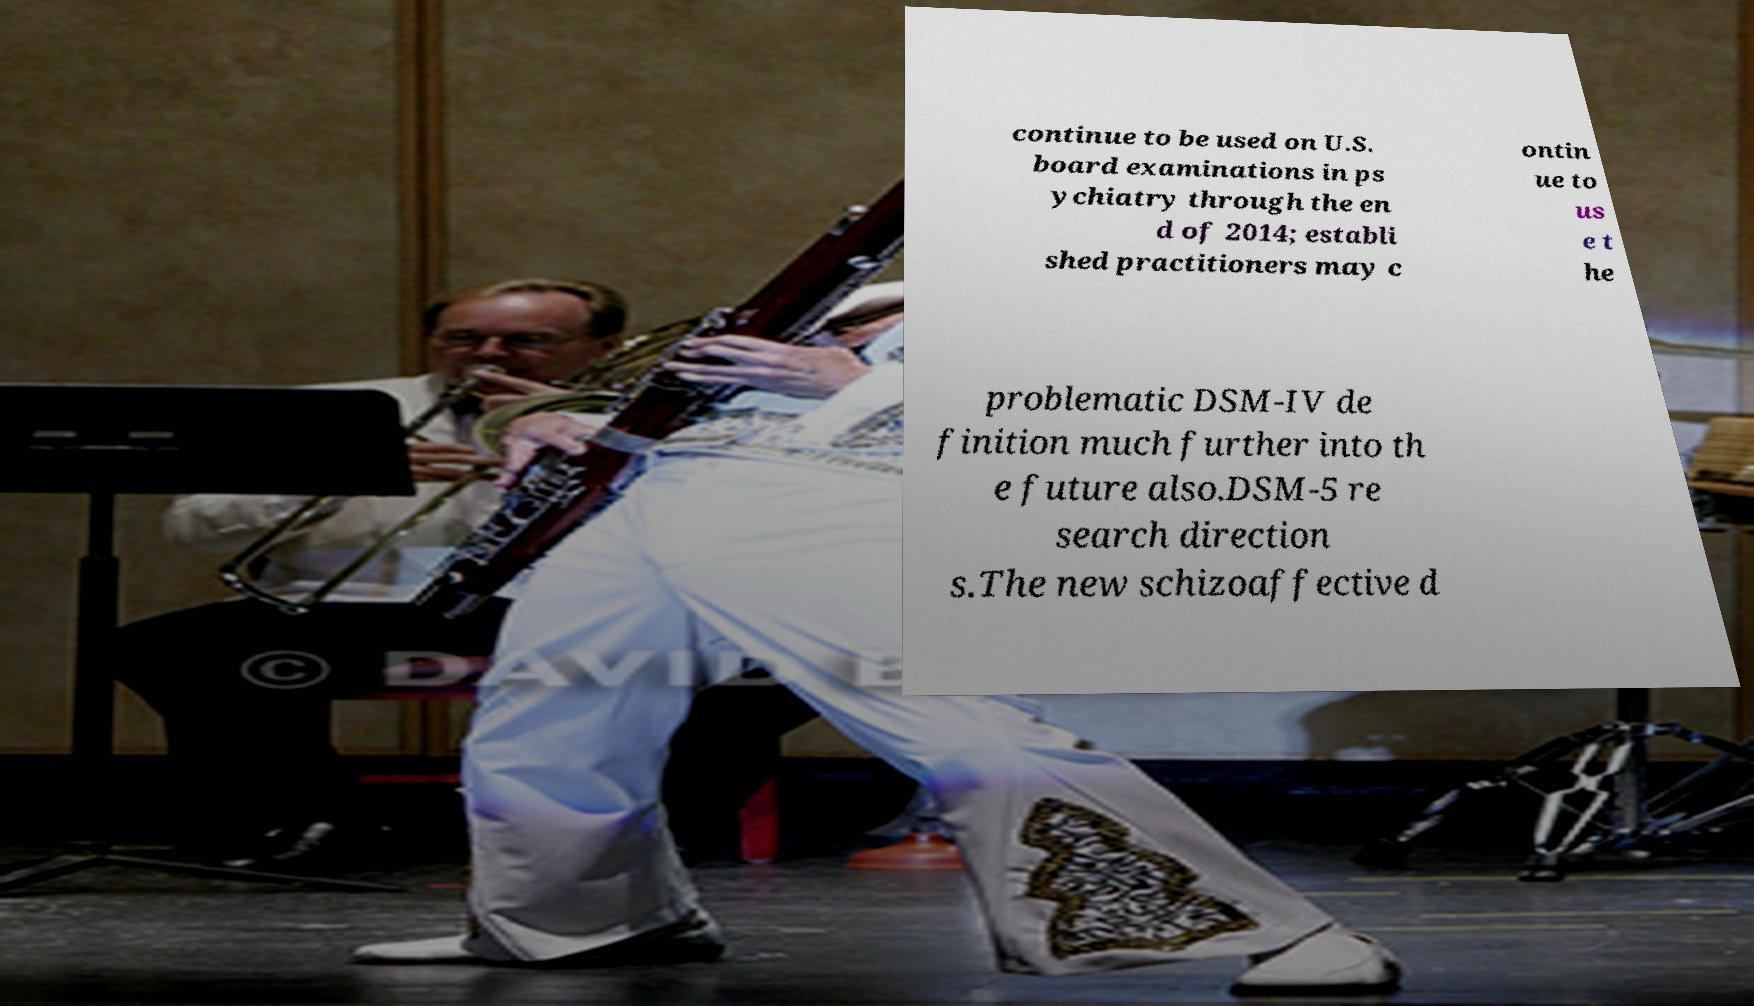For documentation purposes, I need the text within this image transcribed. Could you provide that? continue to be used on U.S. board examinations in ps ychiatry through the en d of 2014; establi shed practitioners may c ontin ue to us e t he problematic DSM-IV de finition much further into th e future also.DSM-5 re search direction s.The new schizoaffective d 